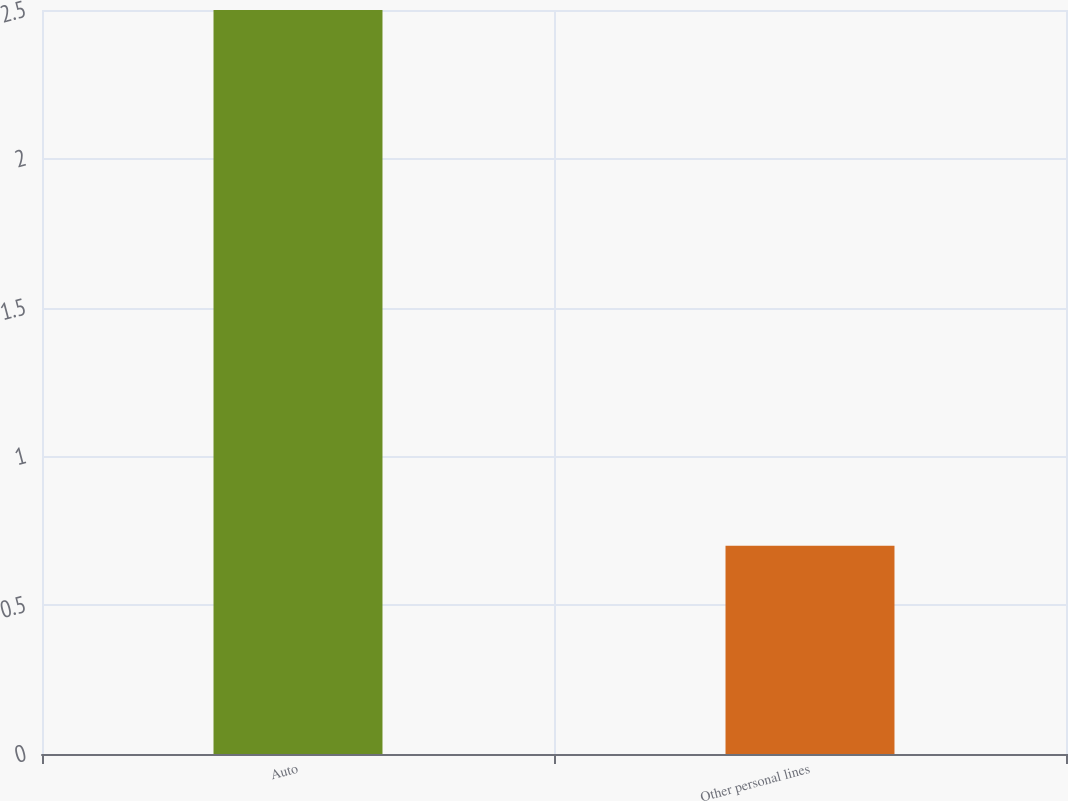<chart> <loc_0><loc_0><loc_500><loc_500><bar_chart><fcel>Auto<fcel>Other personal lines<nl><fcel>2.5<fcel>0.7<nl></chart> 